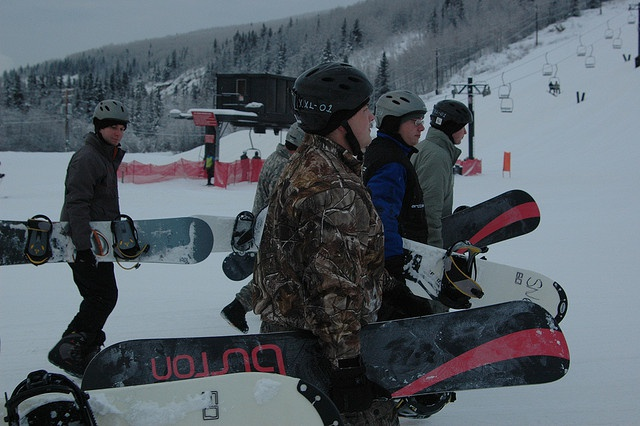Describe the objects in this image and their specific colors. I can see people in gray and black tones, snowboard in gray, black, brown, and darkblue tones, people in gray, black, purple, and darkgray tones, snowboard in gray and black tones, and snowboard in gray, black, blue, and darkblue tones in this image. 